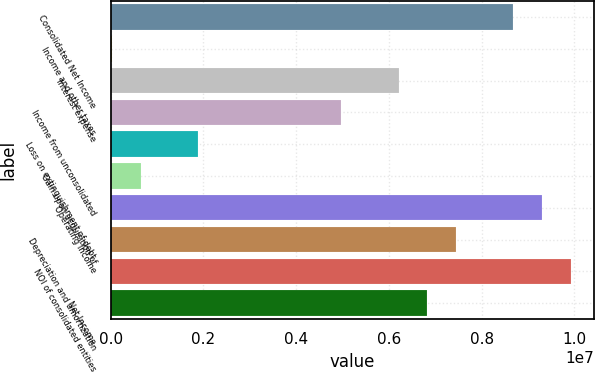Convert chart. <chart><loc_0><loc_0><loc_500><loc_500><bar_chart><fcel>Consolidated Net Income<fcel>Income and other taxes<fcel>Interest expense<fcel>Income from unconsolidated<fcel>Loss on extinguishment of debt<fcel>Gain upon acquisition of<fcel>Operating Income<fcel>Depreciation and amortization<fcel>NOI of consolidated entities<fcel>Net Income<nl><fcel>8.68516e+06<fcel>29678<fcel>6.21216e+06<fcel>4.97567e+06<fcel>1.88442e+06<fcel>647926<fcel>9.3034e+06<fcel>7.44866e+06<fcel>9.92165e+06<fcel>6.83041e+06<nl></chart> 